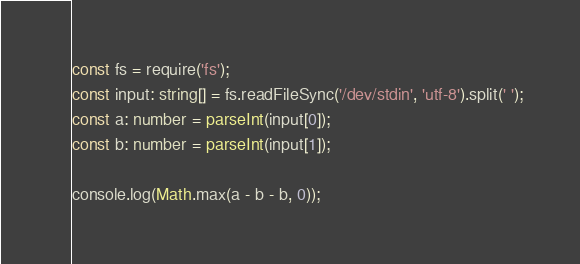<code> <loc_0><loc_0><loc_500><loc_500><_TypeScript_>const fs = require('fs');
const input: string[] = fs.readFileSync('/dev/stdin', 'utf-8').split(' ');
const a: number = parseInt(input[0]);
const b: number = parseInt(input[1]);

console.log(Math.max(a - b - b, 0));</code> 